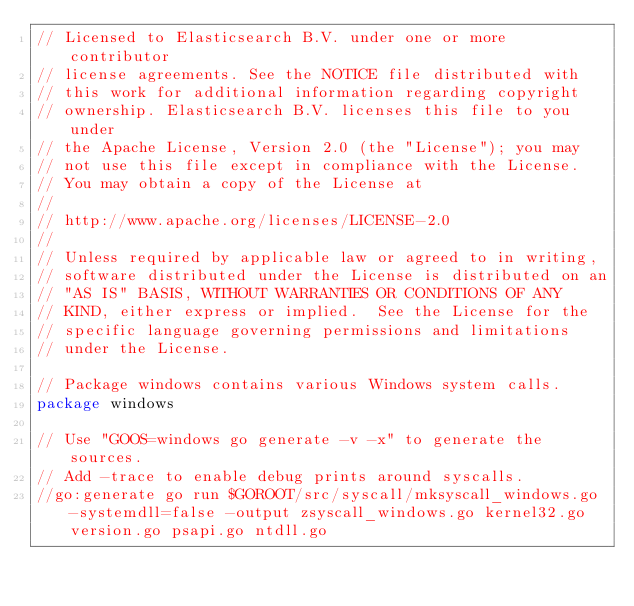Convert code to text. <code><loc_0><loc_0><loc_500><loc_500><_Go_>// Licensed to Elasticsearch B.V. under one or more contributor
// license agreements. See the NOTICE file distributed with
// this work for additional information regarding copyright
// ownership. Elasticsearch B.V. licenses this file to you under
// the Apache License, Version 2.0 (the "License"); you may
// not use this file except in compliance with the License.
// You may obtain a copy of the License at
//
// http://www.apache.org/licenses/LICENSE-2.0
//
// Unless required by applicable law or agreed to in writing,
// software distributed under the License is distributed on an
// "AS IS" BASIS, WITHOUT WARRANTIES OR CONDITIONS OF ANY
// KIND, either express or implied.  See the License for the
// specific language governing permissions and limitations
// under the License.

// Package windows contains various Windows system calls.
package windows

// Use "GOOS=windows go generate -v -x" to generate the sources.
// Add -trace to enable debug prints around syscalls.
//go:generate go run $GOROOT/src/syscall/mksyscall_windows.go -systemdll=false -output zsyscall_windows.go kernel32.go version.go psapi.go ntdll.go
</code> 